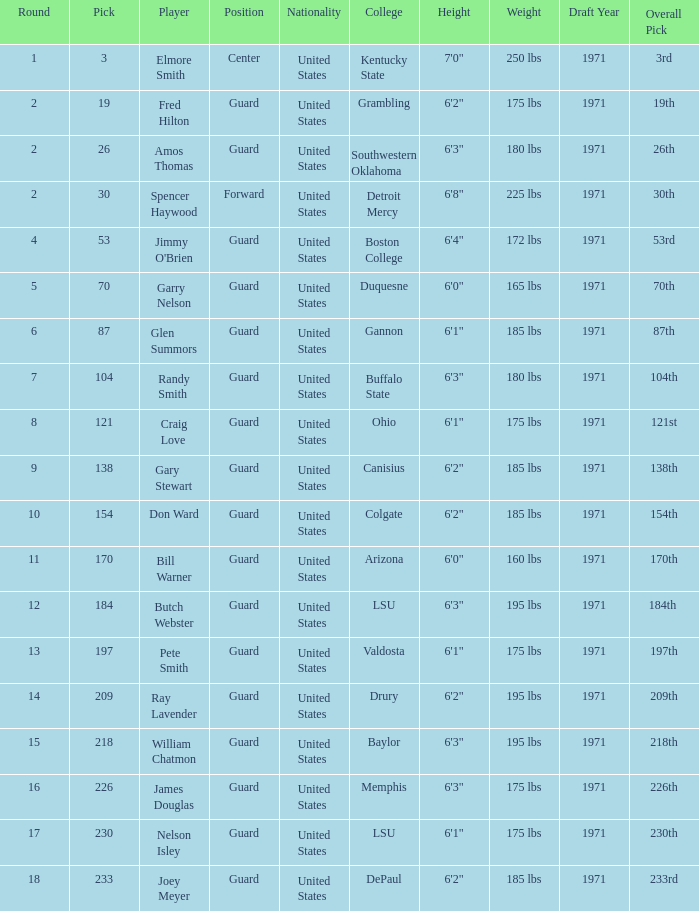WHAT COLLEGE HAS A ROUND LARGER THAN 9, WITH BUTCH WEBSTER? LSU. 